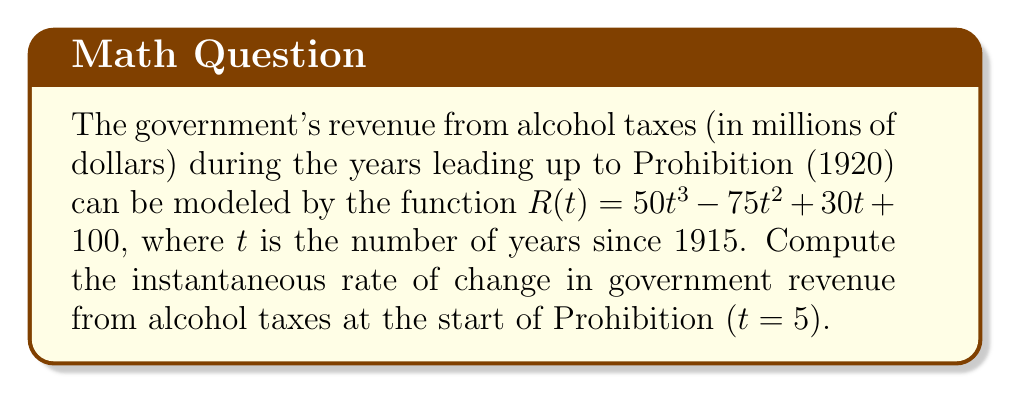Help me with this question. To find the instantaneous rate of change, we need to calculate the derivative of the revenue function $R(t)$ and evaluate it at $t = 5$.

Step 1: Find the derivative of $R(t)$
$$R(t) = 50t^3 - 75t^2 + 30t + 100$$
$$R'(t) = 150t^2 - 150t + 30$$

Step 2: Evaluate $R'(t)$ at $t = 5$
$$R'(5) = 150(5)^2 - 150(5) + 30$$
$$R'(5) = 150(25) - 750 + 30$$
$$R'(5) = 3750 - 750 + 30$$
$$R'(5) = 3030$$

The instantaneous rate of change is 3030 million dollars per year, or $3.03 billion per year.
Answer: $3.03$ billion per year 